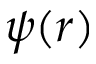Convert formula to latex. <formula><loc_0><loc_0><loc_500><loc_500>\psi ( r )</formula> 